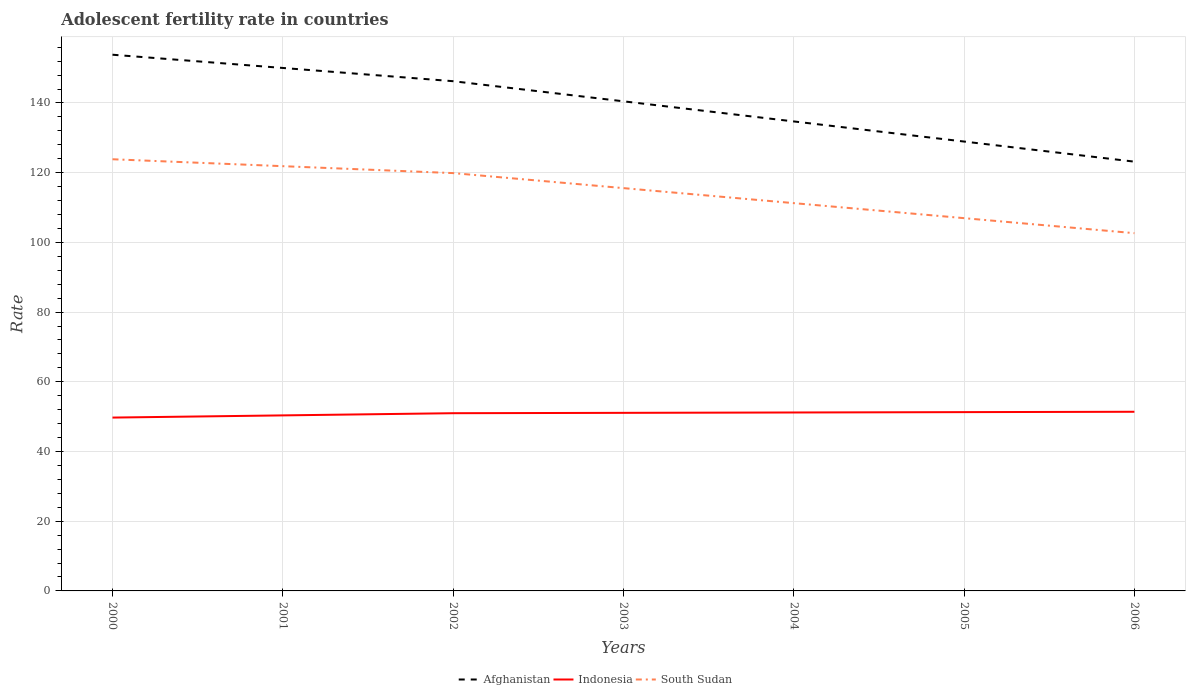Across all years, what is the maximum adolescent fertility rate in Indonesia?
Make the answer very short. 49.73. In which year was the adolescent fertility rate in South Sudan maximum?
Your answer should be very brief. 2006. What is the total adolescent fertility rate in Afghanistan in the graph?
Ensure brevity in your answer.  5.77. What is the difference between the highest and the second highest adolescent fertility rate in Indonesia?
Your answer should be very brief. 1.67. How many lines are there?
Offer a terse response. 3. How many years are there in the graph?
Your response must be concise. 7. What is the difference between two consecutive major ticks on the Y-axis?
Give a very brief answer. 20. Are the values on the major ticks of Y-axis written in scientific E-notation?
Your answer should be very brief. No. Does the graph contain grids?
Give a very brief answer. Yes. Where does the legend appear in the graph?
Provide a short and direct response. Bottom center. How are the legend labels stacked?
Offer a very short reply. Horizontal. What is the title of the graph?
Provide a short and direct response. Adolescent fertility rate in countries. What is the label or title of the X-axis?
Give a very brief answer. Years. What is the label or title of the Y-axis?
Ensure brevity in your answer.  Rate. What is the Rate in Afghanistan in 2000?
Offer a very short reply. 153.85. What is the Rate in Indonesia in 2000?
Your response must be concise. 49.73. What is the Rate in South Sudan in 2000?
Ensure brevity in your answer.  123.85. What is the Rate in Afghanistan in 2001?
Your answer should be very brief. 150.05. What is the Rate of Indonesia in 2001?
Provide a short and direct response. 50.36. What is the Rate of South Sudan in 2001?
Your response must be concise. 121.87. What is the Rate of Afghanistan in 2002?
Keep it short and to the point. 146.25. What is the Rate in Indonesia in 2002?
Provide a short and direct response. 50.99. What is the Rate in South Sudan in 2002?
Keep it short and to the point. 119.88. What is the Rate in Afghanistan in 2003?
Offer a terse response. 140.48. What is the Rate in Indonesia in 2003?
Provide a short and direct response. 51.09. What is the Rate in South Sudan in 2003?
Give a very brief answer. 115.57. What is the Rate of Afghanistan in 2004?
Offer a very short reply. 134.7. What is the Rate in Indonesia in 2004?
Offer a very short reply. 51.2. What is the Rate in South Sudan in 2004?
Make the answer very short. 111.26. What is the Rate in Afghanistan in 2005?
Ensure brevity in your answer.  128.93. What is the Rate in Indonesia in 2005?
Your response must be concise. 51.3. What is the Rate of South Sudan in 2005?
Ensure brevity in your answer.  106.95. What is the Rate in Afghanistan in 2006?
Offer a very short reply. 123.16. What is the Rate of Indonesia in 2006?
Ensure brevity in your answer.  51.4. What is the Rate in South Sudan in 2006?
Keep it short and to the point. 102.64. Across all years, what is the maximum Rate of Afghanistan?
Provide a succinct answer. 153.85. Across all years, what is the maximum Rate of Indonesia?
Your answer should be compact. 51.4. Across all years, what is the maximum Rate in South Sudan?
Give a very brief answer. 123.85. Across all years, what is the minimum Rate of Afghanistan?
Provide a succinct answer. 123.16. Across all years, what is the minimum Rate of Indonesia?
Keep it short and to the point. 49.73. Across all years, what is the minimum Rate of South Sudan?
Your answer should be compact. 102.64. What is the total Rate of Afghanistan in the graph?
Offer a very short reply. 977.42. What is the total Rate of Indonesia in the graph?
Make the answer very short. 356.07. What is the total Rate of South Sudan in the graph?
Offer a terse response. 802.03. What is the difference between the Rate in Afghanistan in 2000 and that in 2001?
Your answer should be very brief. 3.8. What is the difference between the Rate of Indonesia in 2000 and that in 2001?
Offer a very short reply. -0.63. What is the difference between the Rate in South Sudan in 2000 and that in 2001?
Offer a terse response. 1.99. What is the difference between the Rate of Afghanistan in 2000 and that in 2002?
Ensure brevity in your answer.  7.6. What is the difference between the Rate of Indonesia in 2000 and that in 2002?
Keep it short and to the point. -1.26. What is the difference between the Rate in South Sudan in 2000 and that in 2002?
Your response must be concise. 3.97. What is the difference between the Rate in Afghanistan in 2000 and that in 2003?
Make the answer very short. 13.37. What is the difference between the Rate of Indonesia in 2000 and that in 2003?
Give a very brief answer. -1.36. What is the difference between the Rate of South Sudan in 2000 and that in 2003?
Provide a short and direct response. 8.28. What is the difference between the Rate of Afghanistan in 2000 and that in 2004?
Your answer should be compact. 19.14. What is the difference between the Rate in Indonesia in 2000 and that in 2004?
Your answer should be compact. -1.46. What is the difference between the Rate in South Sudan in 2000 and that in 2004?
Offer a very short reply. 12.59. What is the difference between the Rate of Afghanistan in 2000 and that in 2005?
Your answer should be compact. 24.91. What is the difference between the Rate of Indonesia in 2000 and that in 2005?
Keep it short and to the point. -1.57. What is the difference between the Rate in South Sudan in 2000 and that in 2005?
Your answer should be compact. 16.9. What is the difference between the Rate of Afghanistan in 2000 and that in 2006?
Keep it short and to the point. 30.68. What is the difference between the Rate in Indonesia in 2000 and that in 2006?
Your answer should be compact. -1.67. What is the difference between the Rate in South Sudan in 2000 and that in 2006?
Your answer should be compact. 21.21. What is the difference between the Rate of Afghanistan in 2001 and that in 2002?
Provide a succinct answer. 3.8. What is the difference between the Rate in Indonesia in 2001 and that in 2002?
Ensure brevity in your answer.  -0.63. What is the difference between the Rate in South Sudan in 2001 and that in 2002?
Your response must be concise. 1.99. What is the difference between the Rate in Afghanistan in 2001 and that in 2003?
Offer a very short reply. 9.57. What is the difference between the Rate of Indonesia in 2001 and that in 2003?
Provide a short and direct response. -0.73. What is the difference between the Rate in South Sudan in 2001 and that in 2003?
Your response must be concise. 6.3. What is the difference between the Rate of Afghanistan in 2001 and that in 2004?
Your answer should be very brief. 15.34. What is the difference between the Rate of Indonesia in 2001 and that in 2004?
Ensure brevity in your answer.  -0.83. What is the difference between the Rate of South Sudan in 2001 and that in 2004?
Give a very brief answer. 10.6. What is the difference between the Rate in Afghanistan in 2001 and that in 2005?
Give a very brief answer. 21.11. What is the difference between the Rate of Indonesia in 2001 and that in 2005?
Give a very brief answer. -0.94. What is the difference between the Rate of South Sudan in 2001 and that in 2005?
Keep it short and to the point. 14.91. What is the difference between the Rate of Afghanistan in 2001 and that in 2006?
Ensure brevity in your answer.  26.89. What is the difference between the Rate in Indonesia in 2001 and that in 2006?
Give a very brief answer. -1.04. What is the difference between the Rate in South Sudan in 2001 and that in 2006?
Ensure brevity in your answer.  19.22. What is the difference between the Rate in Afghanistan in 2002 and that in 2003?
Your answer should be very brief. 5.77. What is the difference between the Rate in Indonesia in 2002 and that in 2003?
Provide a succinct answer. -0.1. What is the difference between the Rate in South Sudan in 2002 and that in 2003?
Ensure brevity in your answer.  4.31. What is the difference between the Rate in Afghanistan in 2002 and that in 2004?
Offer a very short reply. 11.54. What is the difference between the Rate in Indonesia in 2002 and that in 2004?
Provide a succinct answer. -0.21. What is the difference between the Rate in South Sudan in 2002 and that in 2004?
Offer a terse response. 8.62. What is the difference between the Rate of Afghanistan in 2002 and that in 2005?
Make the answer very short. 17.31. What is the difference between the Rate in Indonesia in 2002 and that in 2005?
Offer a terse response. -0.31. What is the difference between the Rate in South Sudan in 2002 and that in 2005?
Provide a short and direct response. 12.93. What is the difference between the Rate of Afghanistan in 2002 and that in 2006?
Offer a terse response. 23.09. What is the difference between the Rate in Indonesia in 2002 and that in 2006?
Give a very brief answer. -0.41. What is the difference between the Rate in South Sudan in 2002 and that in 2006?
Provide a short and direct response. 17.24. What is the difference between the Rate in Afghanistan in 2003 and that in 2004?
Offer a terse response. 5.77. What is the difference between the Rate of Indonesia in 2003 and that in 2004?
Your answer should be very brief. -0.1. What is the difference between the Rate of South Sudan in 2003 and that in 2004?
Keep it short and to the point. 4.31. What is the difference between the Rate in Afghanistan in 2003 and that in 2005?
Your answer should be very brief. 11.54. What is the difference between the Rate of Indonesia in 2003 and that in 2005?
Provide a succinct answer. -0.21. What is the difference between the Rate in South Sudan in 2003 and that in 2005?
Offer a very short reply. 8.62. What is the difference between the Rate of Afghanistan in 2003 and that in 2006?
Give a very brief answer. 17.31. What is the difference between the Rate in Indonesia in 2003 and that in 2006?
Your answer should be compact. -0.31. What is the difference between the Rate of South Sudan in 2003 and that in 2006?
Your response must be concise. 12.93. What is the difference between the Rate of Afghanistan in 2004 and that in 2005?
Give a very brief answer. 5.77. What is the difference between the Rate in Indonesia in 2004 and that in 2005?
Give a very brief answer. -0.1. What is the difference between the Rate in South Sudan in 2004 and that in 2005?
Provide a succinct answer. 4.31. What is the difference between the Rate of Afghanistan in 2004 and that in 2006?
Your answer should be very brief. 11.54. What is the difference between the Rate in Indonesia in 2004 and that in 2006?
Ensure brevity in your answer.  -0.21. What is the difference between the Rate in South Sudan in 2004 and that in 2006?
Provide a succinct answer. 8.62. What is the difference between the Rate of Afghanistan in 2005 and that in 2006?
Your response must be concise. 5.77. What is the difference between the Rate of Indonesia in 2005 and that in 2006?
Give a very brief answer. -0.1. What is the difference between the Rate in South Sudan in 2005 and that in 2006?
Ensure brevity in your answer.  4.31. What is the difference between the Rate in Afghanistan in 2000 and the Rate in Indonesia in 2001?
Your answer should be compact. 103.48. What is the difference between the Rate in Afghanistan in 2000 and the Rate in South Sudan in 2001?
Offer a terse response. 31.98. What is the difference between the Rate in Indonesia in 2000 and the Rate in South Sudan in 2001?
Ensure brevity in your answer.  -72.13. What is the difference between the Rate in Afghanistan in 2000 and the Rate in Indonesia in 2002?
Provide a short and direct response. 102.86. What is the difference between the Rate of Afghanistan in 2000 and the Rate of South Sudan in 2002?
Your response must be concise. 33.97. What is the difference between the Rate in Indonesia in 2000 and the Rate in South Sudan in 2002?
Provide a short and direct response. -70.15. What is the difference between the Rate of Afghanistan in 2000 and the Rate of Indonesia in 2003?
Keep it short and to the point. 102.75. What is the difference between the Rate in Afghanistan in 2000 and the Rate in South Sudan in 2003?
Make the answer very short. 38.27. What is the difference between the Rate of Indonesia in 2000 and the Rate of South Sudan in 2003?
Ensure brevity in your answer.  -65.84. What is the difference between the Rate of Afghanistan in 2000 and the Rate of Indonesia in 2004?
Provide a short and direct response. 102.65. What is the difference between the Rate in Afghanistan in 2000 and the Rate in South Sudan in 2004?
Offer a very short reply. 42.58. What is the difference between the Rate in Indonesia in 2000 and the Rate in South Sudan in 2004?
Your answer should be very brief. -61.53. What is the difference between the Rate in Afghanistan in 2000 and the Rate in Indonesia in 2005?
Keep it short and to the point. 102.55. What is the difference between the Rate of Afghanistan in 2000 and the Rate of South Sudan in 2005?
Your answer should be very brief. 46.89. What is the difference between the Rate in Indonesia in 2000 and the Rate in South Sudan in 2005?
Provide a succinct answer. -57.22. What is the difference between the Rate of Afghanistan in 2000 and the Rate of Indonesia in 2006?
Ensure brevity in your answer.  102.44. What is the difference between the Rate of Afghanistan in 2000 and the Rate of South Sudan in 2006?
Offer a terse response. 51.2. What is the difference between the Rate in Indonesia in 2000 and the Rate in South Sudan in 2006?
Your response must be concise. -52.91. What is the difference between the Rate in Afghanistan in 2001 and the Rate in Indonesia in 2002?
Offer a terse response. 99.06. What is the difference between the Rate in Afghanistan in 2001 and the Rate in South Sudan in 2002?
Your response must be concise. 30.17. What is the difference between the Rate of Indonesia in 2001 and the Rate of South Sudan in 2002?
Offer a very short reply. -69.52. What is the difference between the Rate in Afghanistan in 2001 and the Rate in Indonesia in 2003?
Give a very brief answer. 98.95. What is the difference between the Rate of Afghanistan in 2001 and the Rate of South Sudan in 2003?
Your answer should be very brief. 34.48. What is the difference between the Rate in Indonesia in 2001 and the Rate in South Sudan in 2003?
Provide a short and direct response. -65.21. What is the difference between the Rate in Afghanistan in 2001 and the Rate in Indonesia in 2004?
Your answer should be compact. 98.85. What is the difference between the Rate in Afghanistan in 2001 and the Rate in South Sudan in 2004?
Provide a short and direct response. 38.78. What is the difference between the Rate in Indonesia in 2001 and the Rate in South Sudan in 2004?
Provide a short and direct response. -60.9. What is the difference between the Rate of Afghanistan in 2001 and the Rate of Indonesia in 2005?
Your response must be concise. 98.75. What is the difference between the Rate of Afghanistan in 2001 and the Rate of South Sudan in 2005?
Provide a succinct answer. 43.09. What is the difference between the Rate in Indonesia in 2001 and the Rate in South Sudan in 2005?
Your answer should be very brief. -56.59. What is the difference between the Rate of Afghanistan in 2001 and the Rate of Indonesia in 2006?
Provide a succinct answer. 98.64. What is the difference between the Rate of Afghanistan in 2001 and the Rate of South Sudan in 2006?
Make the answer very short. 47.4. What is the difference between the Rate of Indonesia in 2001 and the Rate of South Sudan in 2006?
Keep it short and to the point. -52.28. What is the difference between the Rate of Afghanistan in 2002 and the Rate of Indonesia in 2003?
Keep it short and to the point. 95.16. What is the difference between the Rate in Afghanistan in 2002 and the Rate in South Sudan in 2003?
Your answer should be very brief. 30.68. What is the difference between the Rate of Indonesia in 2002 and the Rate of South Sudan in 2003?
Ensure brevity in your answer.  -64.58. What is the difference between the Rate of Afghanistan in 2002 and the Rate of Indonesia in 2004?
Offer a very short reply. 95.05. What is the difference between the Rate in Afghanistan in 2002 and the Rate in South Sudan in 2004?
Provide a short and direct response. 34.99. What is the difference between the Rate of Indonesia in 2002 and the Rate of South Sudan in 2004?
Ensure brevity in your answer.  -60.27. What is the difference between the Rate of Afghanistan in 2002 and the Rate of Indonesia in 2005?
Ensure brevity in your answer.  94.95. What is the difference between the Rate of Afghanistan in 2002 and the Rate of South Sudan in 2005?
Make the answer very short. 39.29. What is the difference between the Rate in Indonesia in 2002 and the Rate in South Sudan in 2005?
Make the answer very short. -55.96. What is the difference between the Rate in Afghanistan in 2002 and the Rate in Indonesia in 2006?
Offer a very short reply. 94.85. What is the difference between the Rate in Afghanistan in 2002 and the Rate in South Sudan in 2006?
Offer a terse response. 43.6. What is the difference between the Rate of Indonesia in 2002 and the Rate of South Sudan in 2006?
Give a very brief answer. -51.65. What is the difference between the Rate in Afghanistan in 2003 and the Rate in Indonesia in 2004?
Give a very brief answer. 89.28. What is the difference between the Rate of Afghanistan in 2003 and the Rate of South Sudan in 2004?
Ensure brevity in your answer.  29.21. What is the difference between the Rate in Indonesia in 2003 and the Rate in South Sudan in 2004?
Make the answer very short. -60.17. What is the difference between the Rate of Afghanistan in 2003 and the Rate of Indonesia in 2005?
Your answer should be compact. 89.18. What is the difference between the Rate in Afghanistan in 2003 and the Rate in South Sudan in 2005?
Your answer should be very brief. 33.52. What is the difference between the Rate in Indonesia in 2003 and the Rate in South Sudan in 2005?
Offer a very short reply. -55.86. What is the difference between the Rate of Afghanistan in 2003 and the Rate of Indonesia in 2006?
Your answer should be very brief. 89.07. What is the difference between the Rate in Afghanistan in 2003 and the Rate in South Sudan in 2006?
Ensure brevity in your answer.  37.83. What is the difference between the Rate in Indonesia in 2003 and the Rate in South Sudan in 2006?
Keep it short and to the point. -51.55. What is the difference between the Rate of Afghanistan in 2004 and the Rate of Indonesia in 2005?
Your response must be concise. 83.41. What is the difference between the Rate of Afghanistan in 2004 and the Rate of South Sudan in 2005?
Your answer should be very brief. 27.75. What is the difference between the Rate in Indonesia in 2004 and the Rate in South Sudan in 2005?
Keep it short and to the point. -55.76. What is the difference between the Rate in Afghanistan in 2004 and the Rate in Indonesia in 2006?
Your answer should be compact. 83.3. What is the difference between the Rate of Afghanistan in 2004 and the Rate of South Sudan in 2006?
Your answer should be compact. 32.06. What is the difference between the Rate in Indonesia in 2004 and the Rate in South Sudan in 2006?
Ensure brevity in your answer.  -51.45. What is the difference between the Rate of Afghanistan in 2005 and the Rate of Indonesia in 2006?
Provide a short and direct response. 77.53. What is the difference between the Rate in Afghanistan in 2005 and the Rate in South Sudan in 2006?
Provide a succinct answer. 26.29. What is the difference between the Rate in Indonesia in 2005 and the Rate in South Sudan in 2006?
Ensure brevity in your answer.  -51.35. What is the average Rate of Afghanistan per year?
Make the answer very short. 139.63. What is the average Rate of Indonesia per year?
Offer a very short reply. 50.87. What is the average Rate in South Sudan per year?
Give a very brief answer. 114.58. In the year 2000, what is the difference between the Rate of Afghanistan and Rate of Indonesia?
Ensure brevity in your answer.  104.11. In the year 2000, what is the difference between the Rate of Afghanistan and Rate of South Sudan?
Offer a very short reply. 29.99. In the year 2000, what is the difference between the Rate of Indonesia and Rate of South Sudan?
Offer a very short reply. -74.12. In the year 2001, what is the difference between the Rate in Afghanistan and Rate in Indonesia?
Your response must be concise. 99.69. In the year 2001, what is the difference between the Rate of Afghanistan and Rate of South Sudan?
Give a very brief answer. 28.18. In the year 2001, what is the difference between the Rate in Indonesia and Rate in South Sudan?
Give a very brief answer. -71.5. In the year 2002, what is the difference between the Rate in Afghanistan and Rate in Indonesia?
Provide a succinct answer. 95.26. In the year 2002, what is the difference between the Rate in Afghanistan and Rate in South Sudan?
Give a very brief answer. 26.37. In the year 2002, what is the difference between the Rate in Indonesia and Rate in South Sudan?
Your answer should be compact. -68.89. In the year 2003, what is the difference between the Rate in Afghanistan and Rate in Indonesia?
Your answer should be compact. 89.38. In the year 2003, what is the difference between the Rate in Afghanistan and Rate in South Sudan?
Ensure brevity in your answer.  24.91. In the year 2003, what is the difference between the Rate of Indonesia and Rate of South Sudan?
Your response must be concise. -64.48. In the year 2004, what is the difference between the Rate in Afghanistan and Rate in Indonesia?
Keep it short and to the point. 83.51. In the year 2004, what is the difference between the Rate of Afghanistan and Rate of South Sudan?
Make the answer very short. 23.44. In the year 2004, what is the difference between the Rate in Indonesia and Rate in South Sudan?
Ensure brevity in your answer.  -60.07. In the year 2005, what is the difference between the Rate in Afghanistan and Rate in Indonesia?
Offer a terse response. 77.63. In the year 2005, what is the difference between the Rate of Afghanistan and Rate of South Sudan?
Ensure brevity in your answer.  21.98. In the year 2005, what is the difference between the Rate of Indonesia and Rate of South Sudan?
Give a very brief answer. -55.65. In the year 2006, what is the difference between the Rate in Afghanistan and Rate in Indonesia?
Give a very brief answer. 71.76. In the year 2006, what is the difference between the Rate in Afghanistan and Rate in South Sudan?
Offer a terse response. 20.52. In the year 2006, what is the difference between the Rate of Indonesia and Rate of South Sudan?
Give a very brief answer. -51.24. What is the ratio of the Rate in Afghanistan in 2000 to that in 2001?
Offer a terse response. 1.03. What is the ratio of the Rate of Indonesia in 2000 to that in 2001?
Keep it short and to the point. 0.99. What is the ratio of the Rate in South Sudan in 2000 to that in 2001?
Provide a succinct answer. 1.02. What is the ratio of the Rate of Afghanistan in 2000 to that in 2002?
Keep it short and to the point. 1.05. What is the ratio of the Rate in Indonesia in 2000 to that in 2002?
Provide a succinct answer. 0.98. What is the ratio of the Rate of South Sudan in 2000 to that in 2002?
Your response must be concise. 1.03. What is the ratio of the Rate in Afghanistan in 2000 to that in 2003?
Keep it short and to the point. 1.1. What is the ratio of the Rate of Indonesia in 2000 to that in 2003?
Give a very brief answer. 0.97. What is the ratio of the Rate of South Sudan in 2000 to that in 2003?
Provide a short and direct response. 1.07. What is the ratio of the Rate of Afghanistan in 2000 to that in 2004?
Provide a short and direct response. 1.14. What is the ratio of the Rate in Indonesia in 2000 to that in 2004?
Offer a very short reply. 0.97. What is the ratio of the Rate of South Sudan in 2000 to that in 2004?
Provide a short and direct response. 1.11. What is the ratio of the Rate in Afghanistan in 2000 to that in 2005?
Provide a succinct answer. 1.19. What is the ratio of the Rate of Indonesia in 2000 to that in 2005?
Your answer should be compact. 0.97. What is the ratio of the Rate of South Sudan in 2000 to that in 2005?
Give a very brief answer. 1.16. What is the ratio of the Rate in Afghanistan in 2000 to that in 2006?
Your answer should be compact. 1.25. What is the ratio of the Rate of Indonesia in 2000 to that in 2006?
Offer a terse response. 0.97. What is the ratio of the Rate in South Sudan in 2000 to that in 2006?
Offer a very short reply. 1.21. What is the ratio of the Rate in Afghanistan in 2001 to that in 2002?
Your response must be concise. 1.03. What is the ratio of the Rate of Indonesia in 2001 to that in 2002?
Ensure brevity in your answer.  0.99. What is the ratio of the Rate in South Sudan in 2001 to that in 2002?
Keep it short and to the point. 1.02. What is the ratio of the Rate of Afghanistan in 2001 to that in 2003?
Your answer should be very brief. 1.07. What is the ratio of the Rate of Indonesia in 2001 to that in 2003?
Give a very brief answer. 0.99. What is the ratio of the Rate of South Sudan in 2001 to that in 2003?
Your answer should be very brief. 1.05. What is the ratio of the Rate in Afghanistan in 2001 to that in 2004?
Your response must be concise. 1.11. What is the ratio of the Rate of Indonesia in 2001 to that in 2004?
Give a very brief answer. 0.98. What is the ratio of the Rate of South Sudan in 2001 to that in 2004?
Provide a succinct answer. 1.1. What is the ratio of the Rate in Afghanistan in 2001 to that in 2005?
Ensure brevity in your answer.  1.16. What is the ratio of the Rate of Indonesia in 2001 to that in 2005?
Your response must be concise. 0.98. What is the ratio of the Rate of South Sudan in 2001 to that in 2005?
Make the answer very short. 1.14. What is the ratio of the Rate in Afghanistan in 2001 to that in 2006?
Provide a succinct answer. 1.22. What is the ratio of the Rate in Indonesia in 2001 to that in 2006?
Offer a very short reply. 0.98. What is the ratio of the Rate in South Sudan in 2001 to that in 2006?
Make the answer very short. 1.19. What is the ratio of the Rate in Afghanistan in 2002 to that in 2003?
Offer a terse response. 1.04. What is the ratio of the Rate in Indonesia in 2002 to that in 2003?
Offer a terse response. 1. What is the ratio of the Rate in South Sudan in 2002 to that in 2003?
Provide a short and direct response. 1.04. What is the ratio of the Rate in Afghanistan in 2002 to that in 2004?
Offer a very short reply. 1.09. What is the ratio of the Rate in South Sudan in 2002 to that in 2004?
Make the answer very short. 1.08. What is the ratio of the Rate of Afghanistan in 2002 to that in 2005?
Give a very brief answer. 1.13. What is the ratio of the Rate of South Sudan in 2002 to that in 2005?
Offer a terse response. 1.12. What is the ratio of the Rate of Afghanistan in 2002 to that in 2006?
Give a very brief answer. 1.19. What is the ratio of the Rate of Indonesia in 2002 to that in 2006?
Your answer should be very brief. 0.99. What is the ratio of the Rate of South Sudan in 2002 to that in 2006?
Provide a succinct answer. 1.17. What is the ratio of the Rate in Afghanistan in 2003 to that in 2004?
Your answer should be very brief. 1.04. What is the ratio of the Rate of South Sudan in 2003 to that in 2004?
Provide a short and direct response. 1.04. What is the ratio of the Rate of Afghanistan in 2003 to that in 2005?
Your response must be concise. 1.09. What is the ratio of the Rate in Indonesia in 2003 to that in 2005?
Your response must be concise. 1. What is the ratio of the Rate of South Sudan in 2003 to that in 2005?
Provide a short and direct response. 1.08. What is the ratio of the Rate of Afghanistan in 2003 to that in 2006?
Your answer should be compact. 1.14. What is the ratio of the Rate of South Sudan in 2003 to that in 2006?
Offer a very short reply. 1.13. What is the ratio of the Rate in Afghanistan in 2004 to that in 2005?
Your answer should be compact. 1.04. What is the ratio of the Rate in South Sudan in 2004 to that in 2005?
Keep it short and to the point. 1.04. What is the ratio of the Rate of Afghanistan in 2004 to that in 2006?
Offer a terse response. 1.09. What is the ratio of the Rate of South Sudan in 2004 to that in 2006?
Offer a very short reply. 1.08. What is the ratio of the Rate of Afghanistan in 2005 to that in 2006?
Offer a terse response. 1.05. What is the ratio of the Rate in Indonesia in 2005 to that in 2006?
Provide a short and direct response. 1. What is the ratio of the Rate of South Sudan in 2005 to that in 2006?
Keep it short and to the point. 1.04. What is the difference between the highest and the second highest Rate in Afghanistan?
Make the answer very short. 3.8. What is the difference between the highest and the second highest Rate of Indonesia?
Ensure brevity in your answer.  0.1. What is the difference between the highest and the second highest Rate of South Sudan?
Your answer should be very brief. 1.99. What is the difference between the highest and the lowest Rate in Afghanistan?
Your answer should be compact. 30.68. What is the difference between the highest and the lowest Rate of Indonesia?
Keep it short and to the point. 1.67. What is the difference between the highest and the lowest Rate in South Sudan?
Your answer should be very brief. 21.21. 